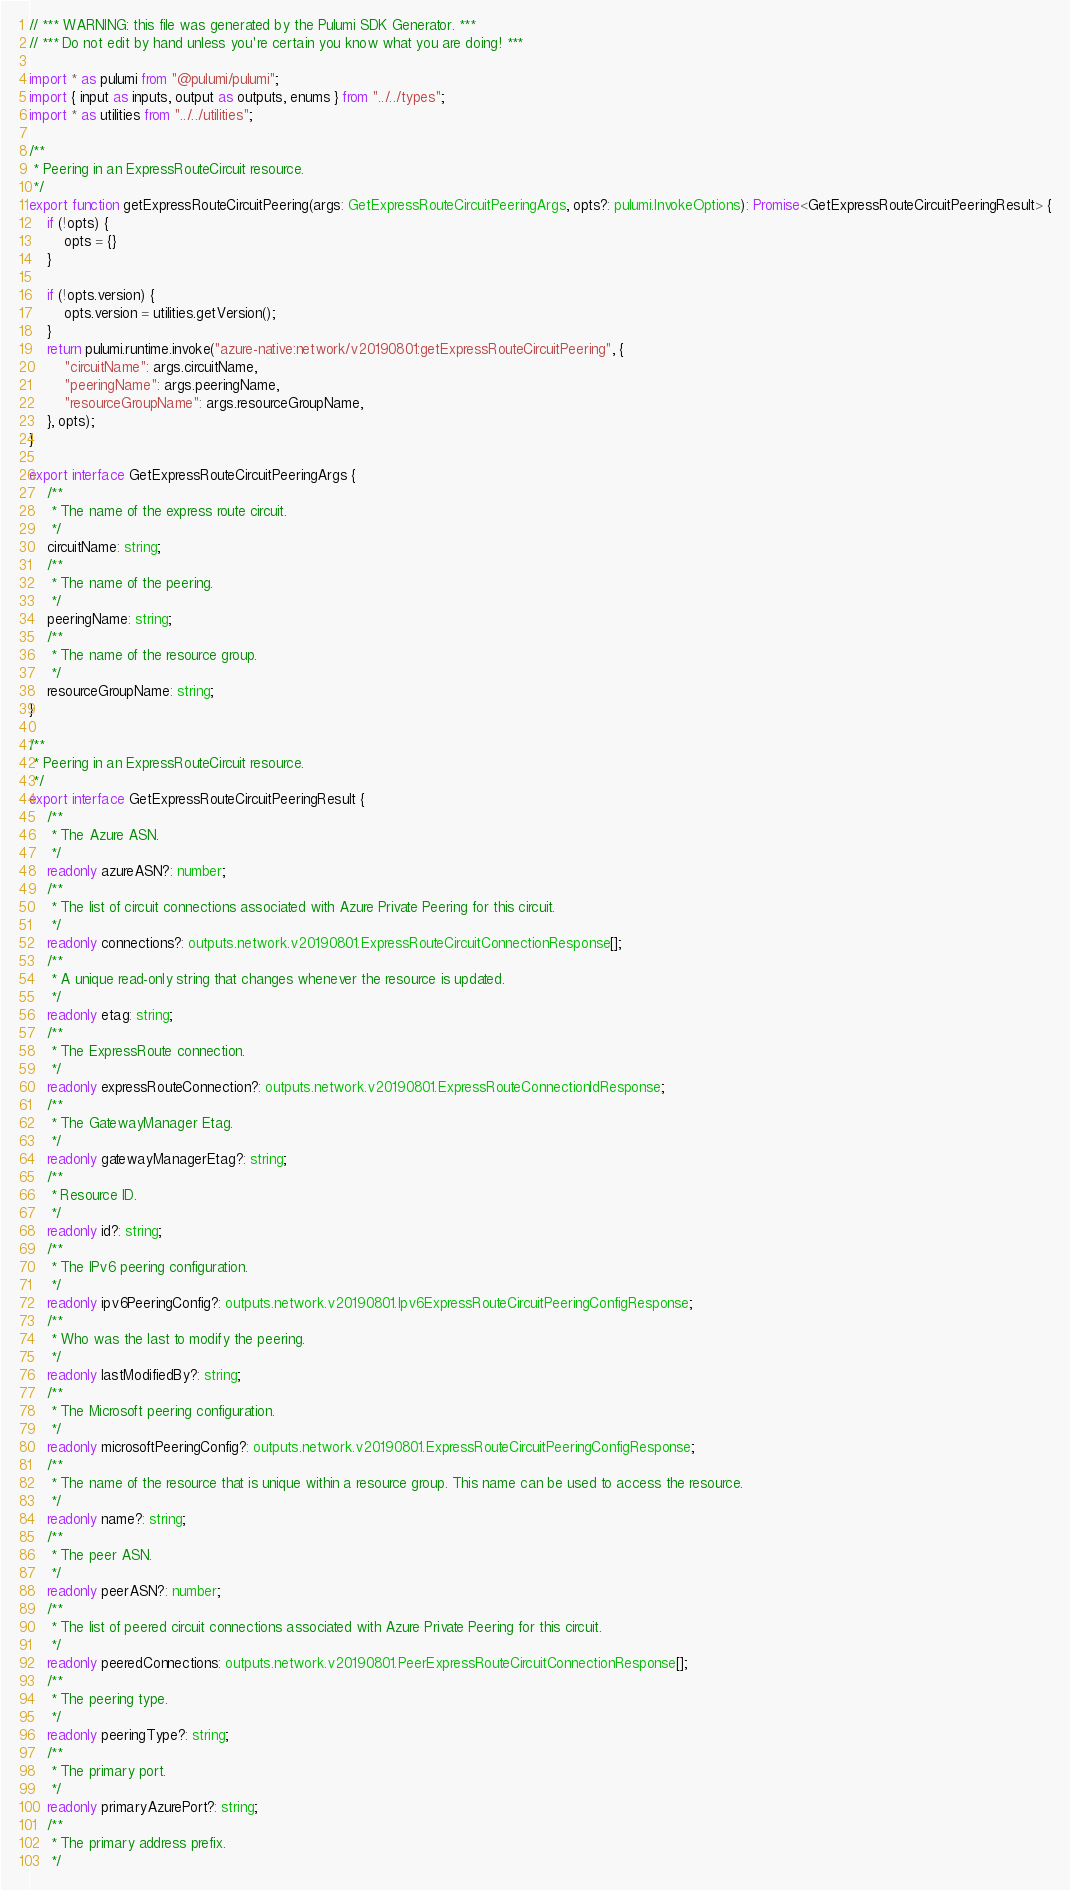Convert code to text. <code><loc_0><loc_0><loc_500><loc_500><_TypeScript_>// *** WARNING: this file was generated by the Pulumi SDK Generator. ***
// *** Do not edit by hand unless you're certain you know what you are doing! ***

import * as pulumi from "@pulumi/pulumi";
import { input as inputs, output as outputs, enums } from "../../types";
import * as utilities from "../../utilities";

/**
 * Peering in an ExpressRouteCircuit resource.
 */
export function getExpressRouteCircuitPeering(args: GetExpressRouteCircuitPeeringArgs, opts?: pulumi.InvokeOptions): Promise<GetExpressRouteCircuitPeeringResult> {
    if (!opts) {
        opts = {}
    }

    if (!opts.version) {
        opts.version = utilities.getVersion();
    }
    return pulumi.runtime.invoke("azure-native:network/v20190801:getExpressRouteCircuitPeering", {
        "circuitName": args.circuitName,
        "peeringName": args.peeringName,
        "resourceGroupName": args.resourceGroupName,
    }, opts);
}

export interface GetExpressRouteCircuitPeeringArgs {
    /**
     * The name of the express route circuit.
     */
    circuitName: string;
    /**
     * The name of the peering.
     */
    peeringName: string;
    /**
     * The name of the resource group.
     */
    resourceGroupName: string;
}

/**
 * Peering in an ExpressRouteCircuit resource.
 */
export interface GetExpressRouteCircuitPeeringResult {
    /**
     * The Azure ASN.
     */
    readonly azureASN?: number;
    /**
     * The list of circuit connections associated with Azure Private Peering for this circuit.
     */
    readonly connections?: outputs.network.v20190801.ExpressRouteCircuitConnectionResponse[];
    /**
     * A unique read-only string that changes whenever the resource is updated.
     */
    readonly etag: string;
    /**
     * The ExpressRoute connection.
     */
    readonly expressRouteConnection?: outputs.network.v20190801.ExpressRouteConnectionIdResponse;
    /**
     * The GatewayManager Etag.
     */
    readonly gatewayManagerEtag?: string;
    /**
     * Resource ID.
     */
    readonly id?: string;
    /**
     * The IPv6 peering configuration.
     */
    readonly ipv6PeeringConfig?: outputs.network.v20190801.Ipv6ExpressRouteCircuitPeeringConfigResponse;
    /**
     * Who was the last to modify the peering.
     */
    readonly lastModifiedBy?: string;
    /**
     * The Microsoft peering configuration.
     */
    readonly microsoftPeeringConfig?: outputs.network.v20190801.ExpressRouteCircuitPeeringConfigResponse;
    /**
     * The name of the resource that is unique within a resource group. This name can be used to access the resource.
     */
    readonly name?: string;
    /**
     * The peer ASN.
     */
    readonly peerASN?: number;
    /**
     * The list of peered circuit connections associated with Azure Private Peering for this circuit.
     */
    readonly peeredConnections: outputs.network.v20190801.PeerExpressRouteCircuitConnectionResponse[];
    /**
     * The peering type.
     */
    readonly peeringType?: string;
    /**
     * The primary port.
     */
    readonly primaryAzurePort?: string;
    /**
     * The primary address prefix.
     */</code> 